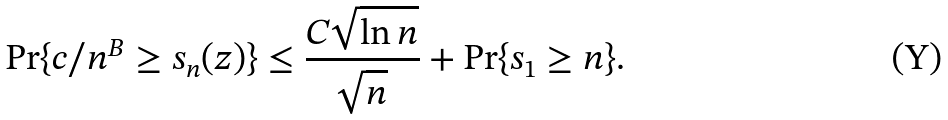Convert formula to latex. <formula><loc_0><loc_0><loc_500><loc_500>\Pr \{ c / n ^ { B } \geq s _ { n } ( z ) \} \leq \frac { C \sqrt { \ln n } } { \sqrt { n } } + \Pr \{ s _ { 1 } \geq n \} .</formula> 